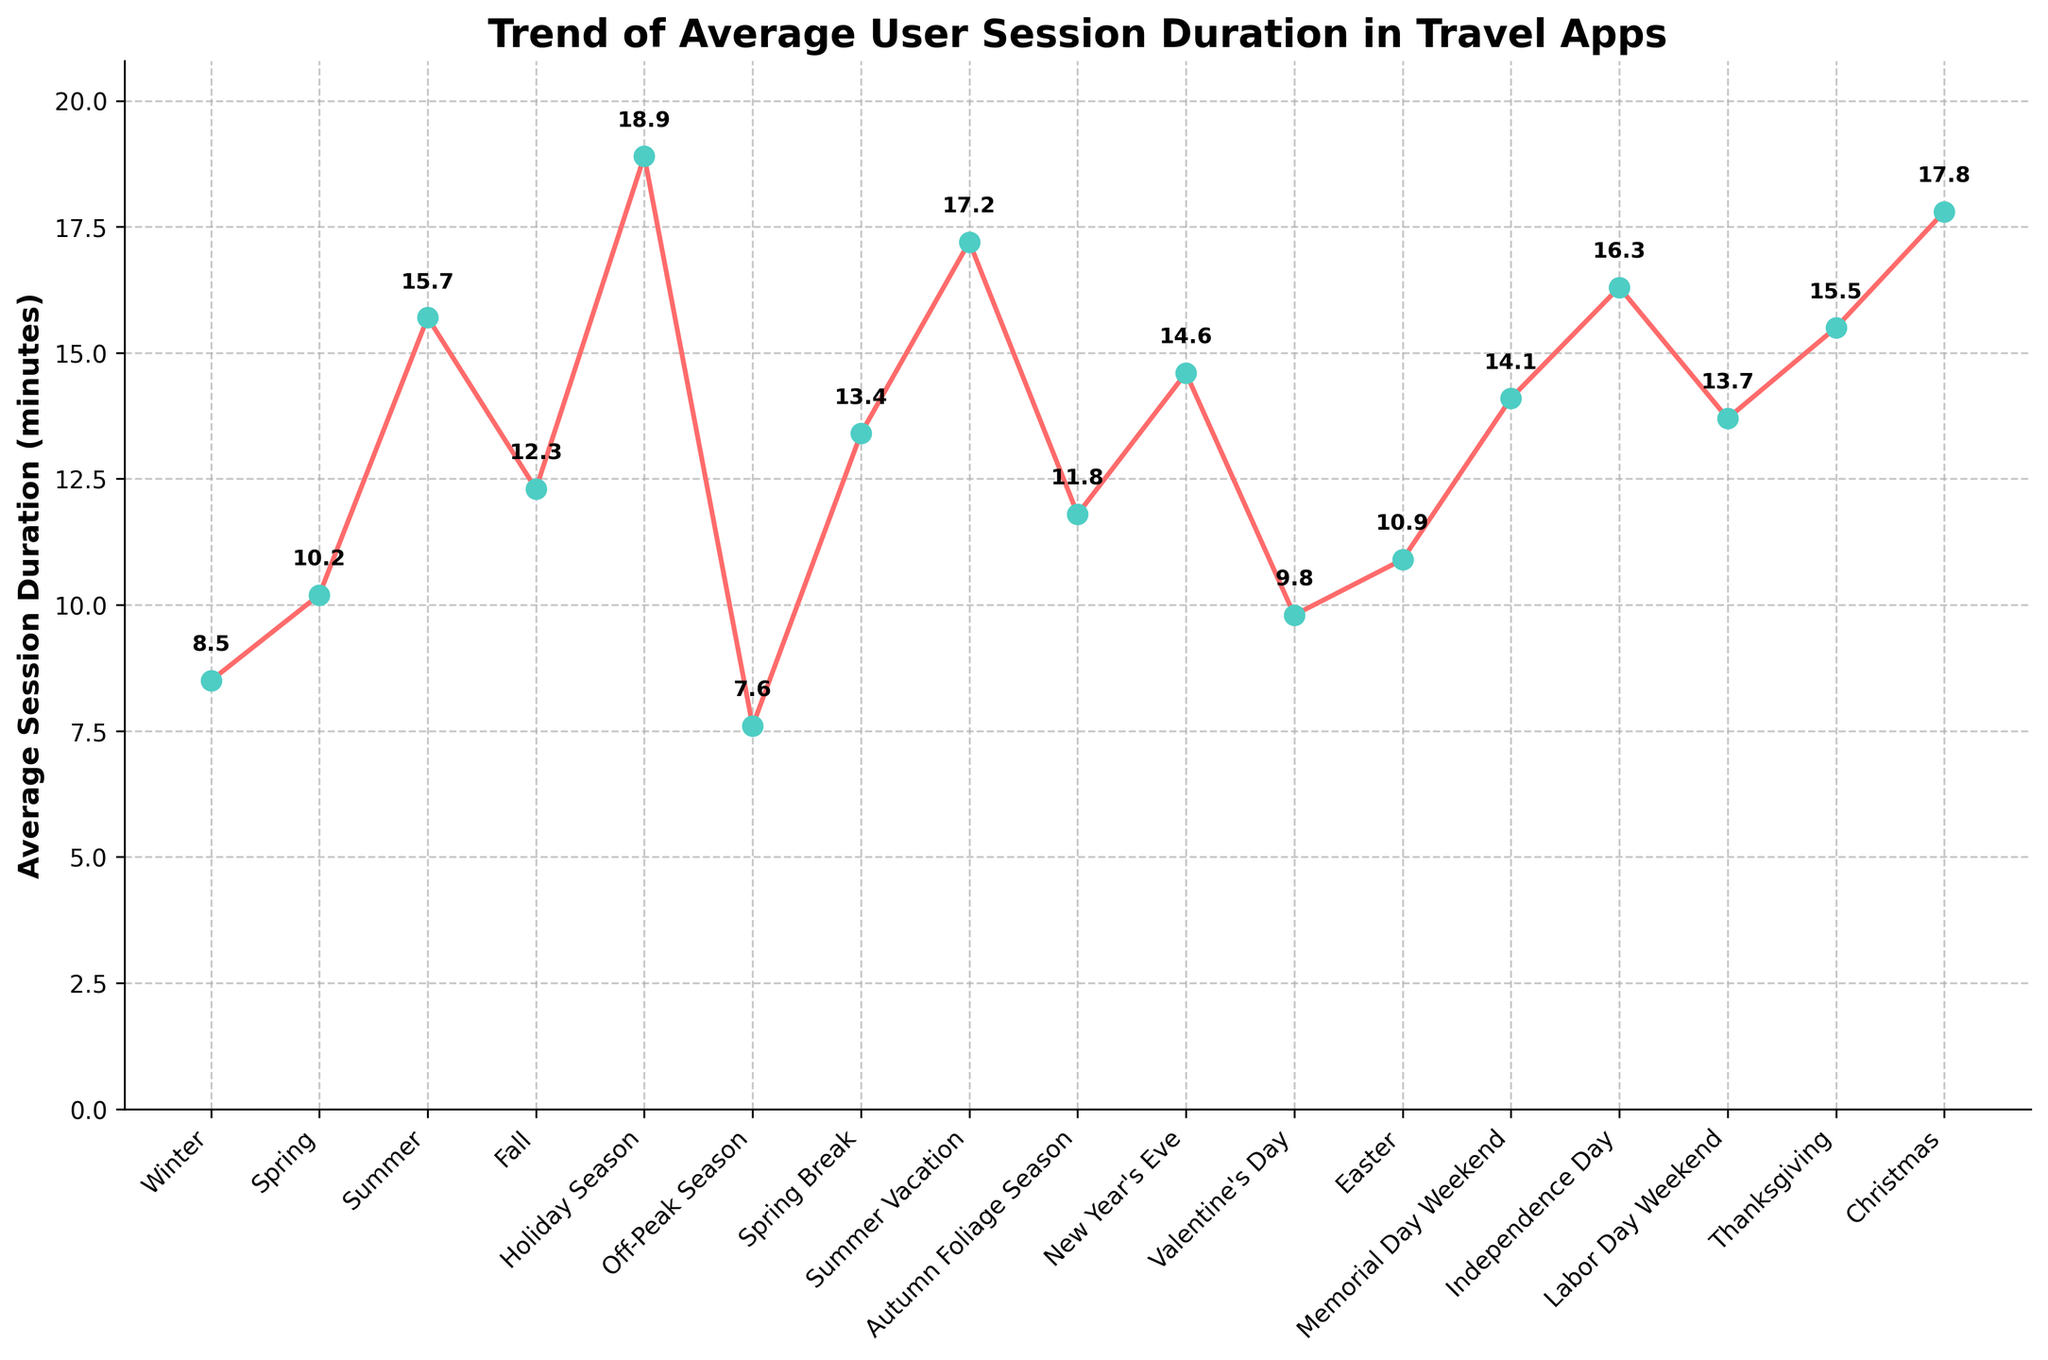Which season has the highest average session duration? From the chart, identify the peak of the line graph and read the corresponding x-axis label for that peak.
Answer: Holiday Season What is the average session duration during Summer Vacation? Locate the point corresponding to "Summer Vacation" on the x-axis and read the y-axis value.
Answer: 17.2 minutes How much higher is the average session duration during Christmas compared to Winter? Find the y-axis values for both "Christmas" and "Winter" and subtract the Winter value from the Christmas value.
Answer: 17.8 - 8.5 = 9.3 minutes What is the trend of average session duration during the spring-related seasons (Spring, Spring Break, and Easter)? Observe the data points for "Spring," "Spring Break," and "Easter" and describe how the values change among these three seasons.
Answer: Increases from Spring (10.2) to Spring Break (13.4), then slightly decreases at Easter (10.9) Compare the session duration of Independence Day and Labor Day Weekend. Which one is higher? Locate the data points for "Independence Day" and "Labor Day Weekend" on the x-axis and compare the y-axis values.
Answer: Independence Day (16.3 minutes) is higher than Labor Day Weekend (13.7 minutes) Combining the session durations of both Independence Day and Thanksgiving, what is the total time spent? Add the average session durations for "Independence Day" and "Thanksgiving."
Answer: 16.3 + 15.5 = 31.8 minutes How does the session duration of New Year's Eve compare to Memorial Day Weekend? Identify the y-axis values for both “New Year's Eve” and “Memorial Day Weekend” and compare them to determine which is higher.
Answer: Memorial Day Weekend is slightly higher at 14.1 minutes compared to New Year's Eve at 14.6 minutes 